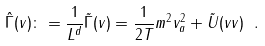Convert formula to latex. <formula><loc_0><loc_0><loc_500><loc_500>\hat { \Gamma } ( v ) \colon = \frac { 1 } { L ^ { d } } \tilde { \Gamma } ( v ) = \frac { 1 } { 2 T } m ^ { 2 } v _ { a } ^ { 2 } + \tilde { U } ( v v ) \ .</formula> 